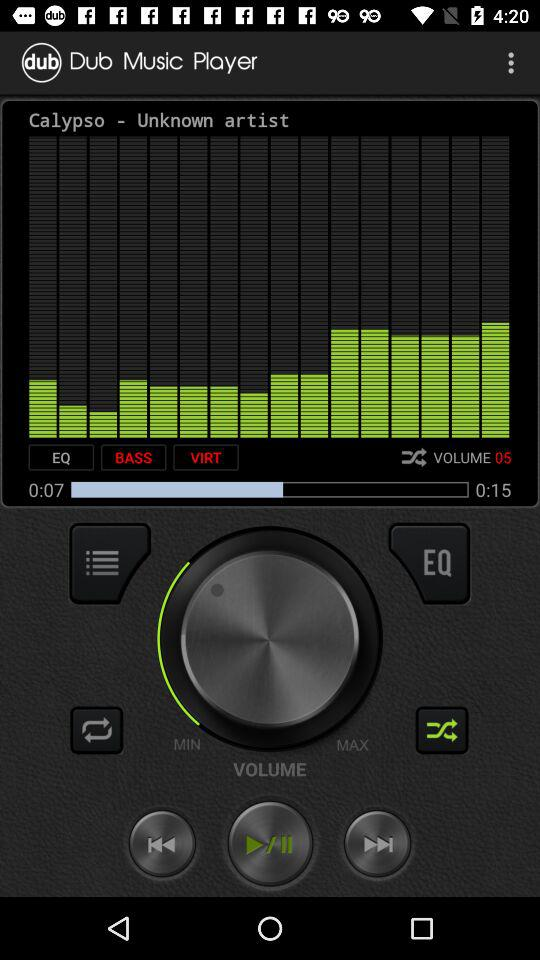What is the time duration of the audio? The time duration of the audio is 15 seconds. 